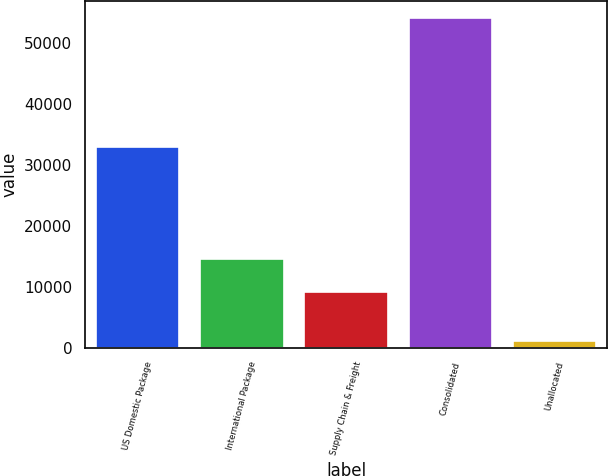Convert chart to OTSL. <chart><loc_0><loc_0><loc_500><loc_500><bar_chart><fcel>US Domestic Package<fcel>International Package<fcel>Supply Chain & Freight<fcel>Consolidated<fcel>Unallocated<nl><fcel>32856<fcel>14452.6<fcel>9147<fcel>54127<fcel>1071<nl></chart> 